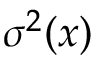Convert formula to latex. <formula><loc_0><loc_0><loc_500><loc_500>\sigma ^ { 2 } ( x )</formula> 